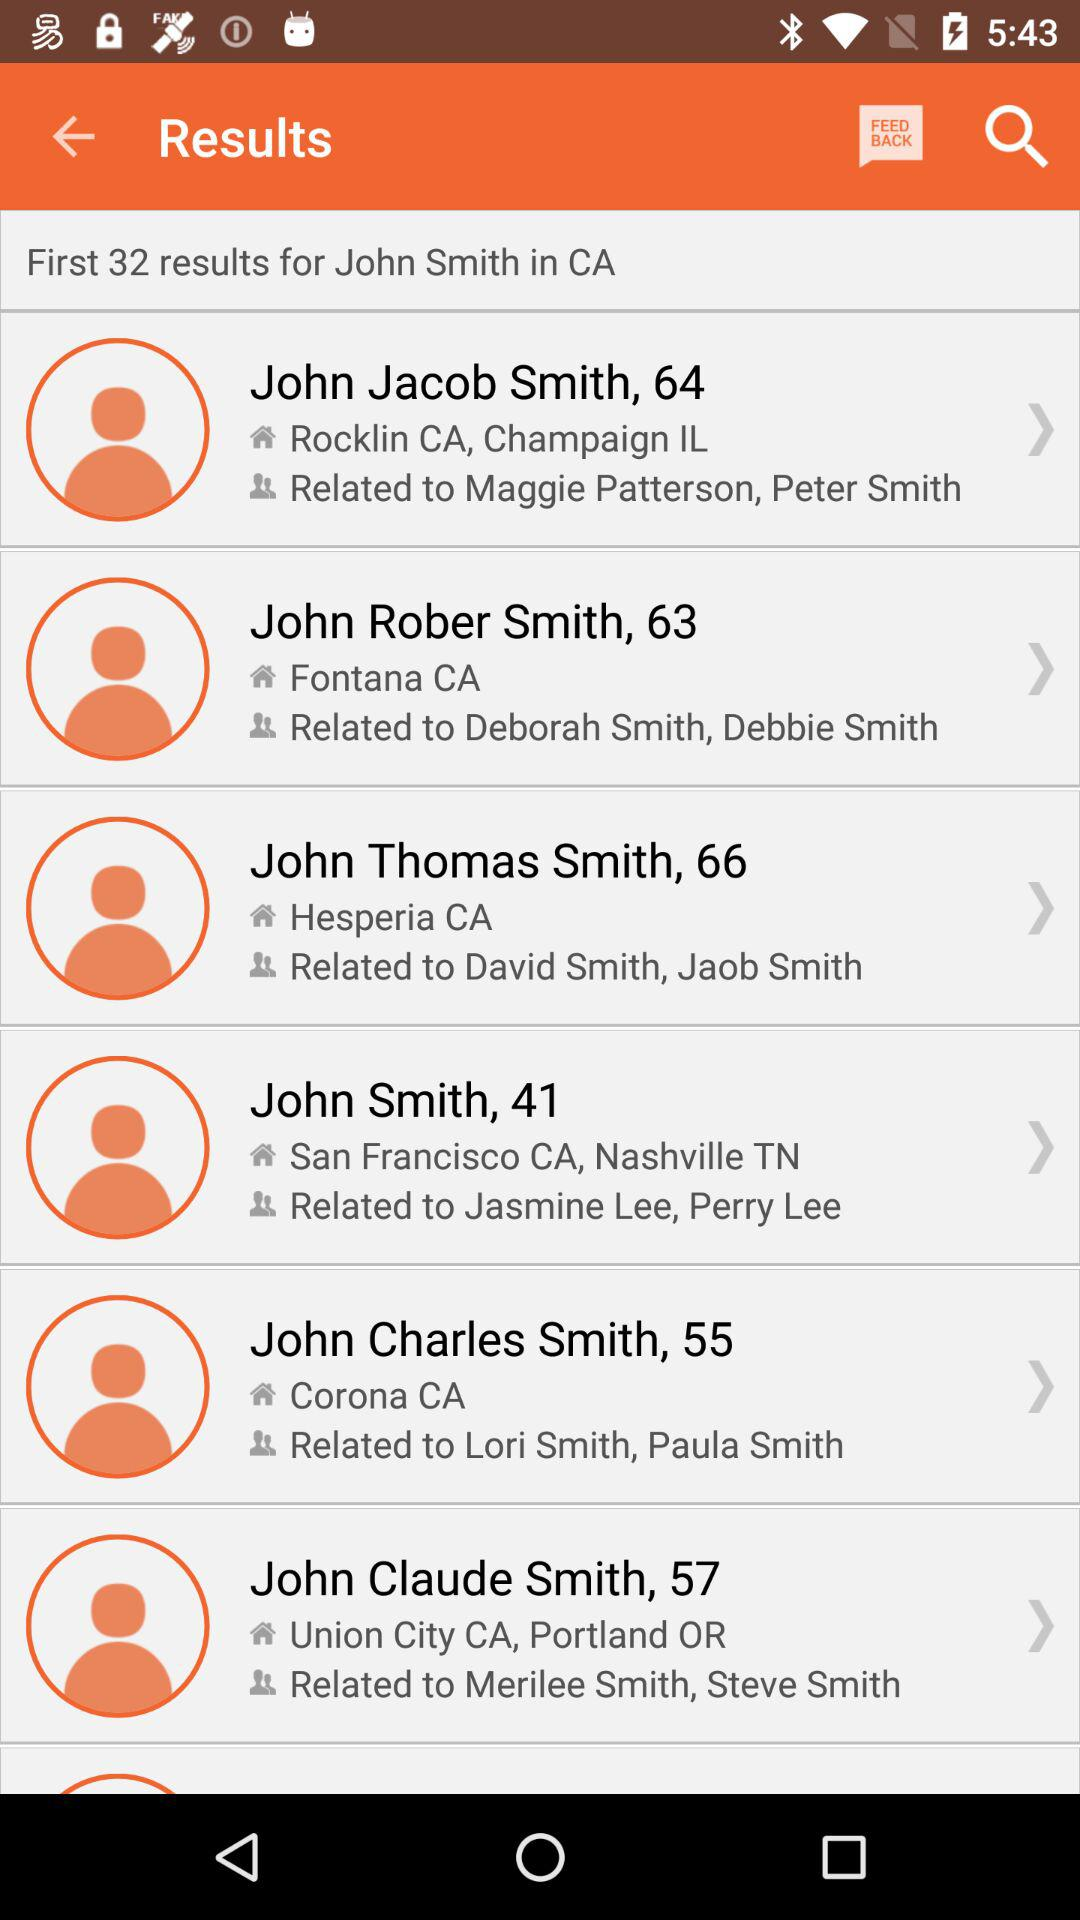How many results are there for John Smith in CA?
Answer the question using a single word or phrase. 32 